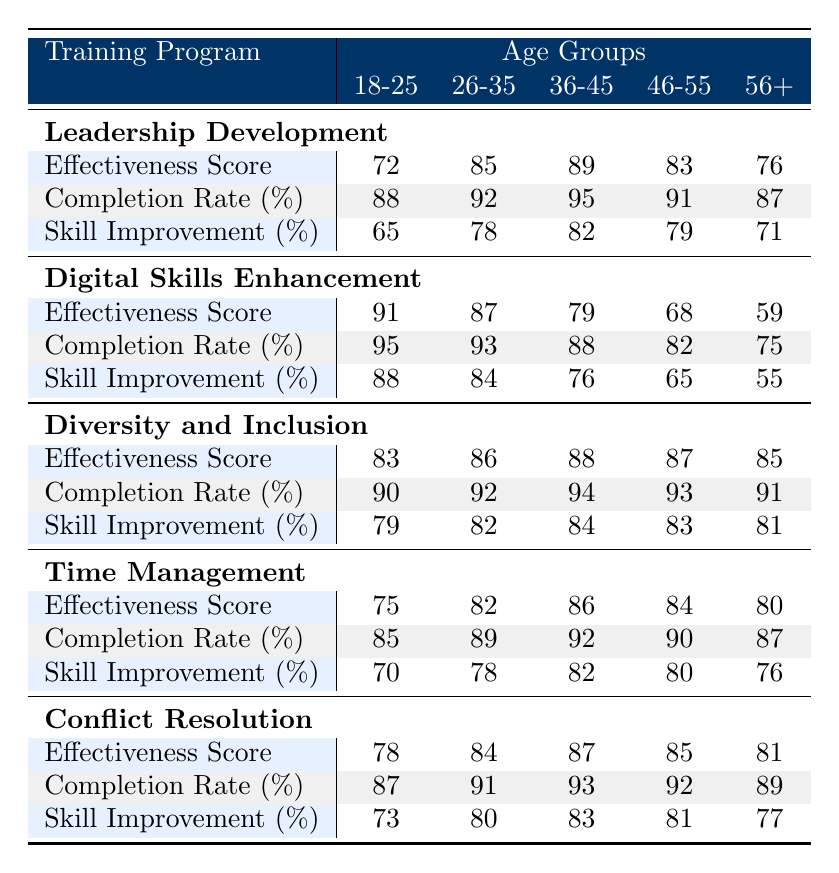What is the effectiveness score for the "Leadership Development" program among the age group 36-45? The table indicates that the effectiveness score for the "Leadership Development" program in the age group 36-45 is 89.
Answer: 89 What is the completion rate for the "Digital Skills Enhancement" program for age group 56+? According to the table, the completion rate for the "Digital Skills Enhancement" program in the age group 56+ is 75%.
Answer: 75% Which training program had the highest skill improvement score across all age groups? By reviewing the skill improvement scores for each training program, "Digital Skills Enhancement" has the highest score of 88 in the age group 18-25, which is the maximum across all age groups.
Answer: Yes, it is "Digital Skills Enhancement" What is the average effectiveness score for the "Diversity and Inclusion" program across all age groups? To calculate the average, we sum the effectiveness scores: 83 + 86 + 88 + 87 + 85 = 429. Dividing 429 by 5 gives an average of 85.8.
Answer: 85.8 Is the completion rate for the "Time Management" program higher than 90% for age group 46-55? The table shows that the completion rate for the "Time Management" program for the age group 46-55 is 90%, which is equal to 90%, but not greater.
Answer: No What is the percentage difference in effectiveness scores between the "Conflict Resolution" program for the age groups 18-25 and 56+? The effectiveness score for the "Conflict Resolution" program in the age group 18-25 is 78, and for age group 56+ it's 81. The difference is 81 - 78 = 3. To find the percentage difference, we use the formula (Difference / Lower score) * 100 = (3 / 78) * 100, which gives approximately 3.85%.
Answer: 3.85% Which age group had the lowest skill improvement among all training programs? By reviewing the skill improvement scores for all the age groups, the lowest score was for the "Digital Skills Enhancement" in age group 56+, which had a skill improvement of 55%.
Answer: Age group 56+ What is the sum of completion rates for the "Leadership Development" program across all age groups? The completion rates for the "Leadership Development" program are 88, 92, 95, 91, and 87. Summing these gives: 88 + 92 + 95 + 91 + 87 = 453.
Answer: 453 What is the highest skill improvement percentage achieved in the 36-45 age group across all training programs? In the 36-45 age group, the skill improvement scores are: Leadership Development (82), Digital Skills Enhancement (76), Diversity and Inclusion (84), Time Management (82), and Conflict Resolution (83). The highest score is 84 from the "Diversity and Inclusion" program.
Answer: 84 